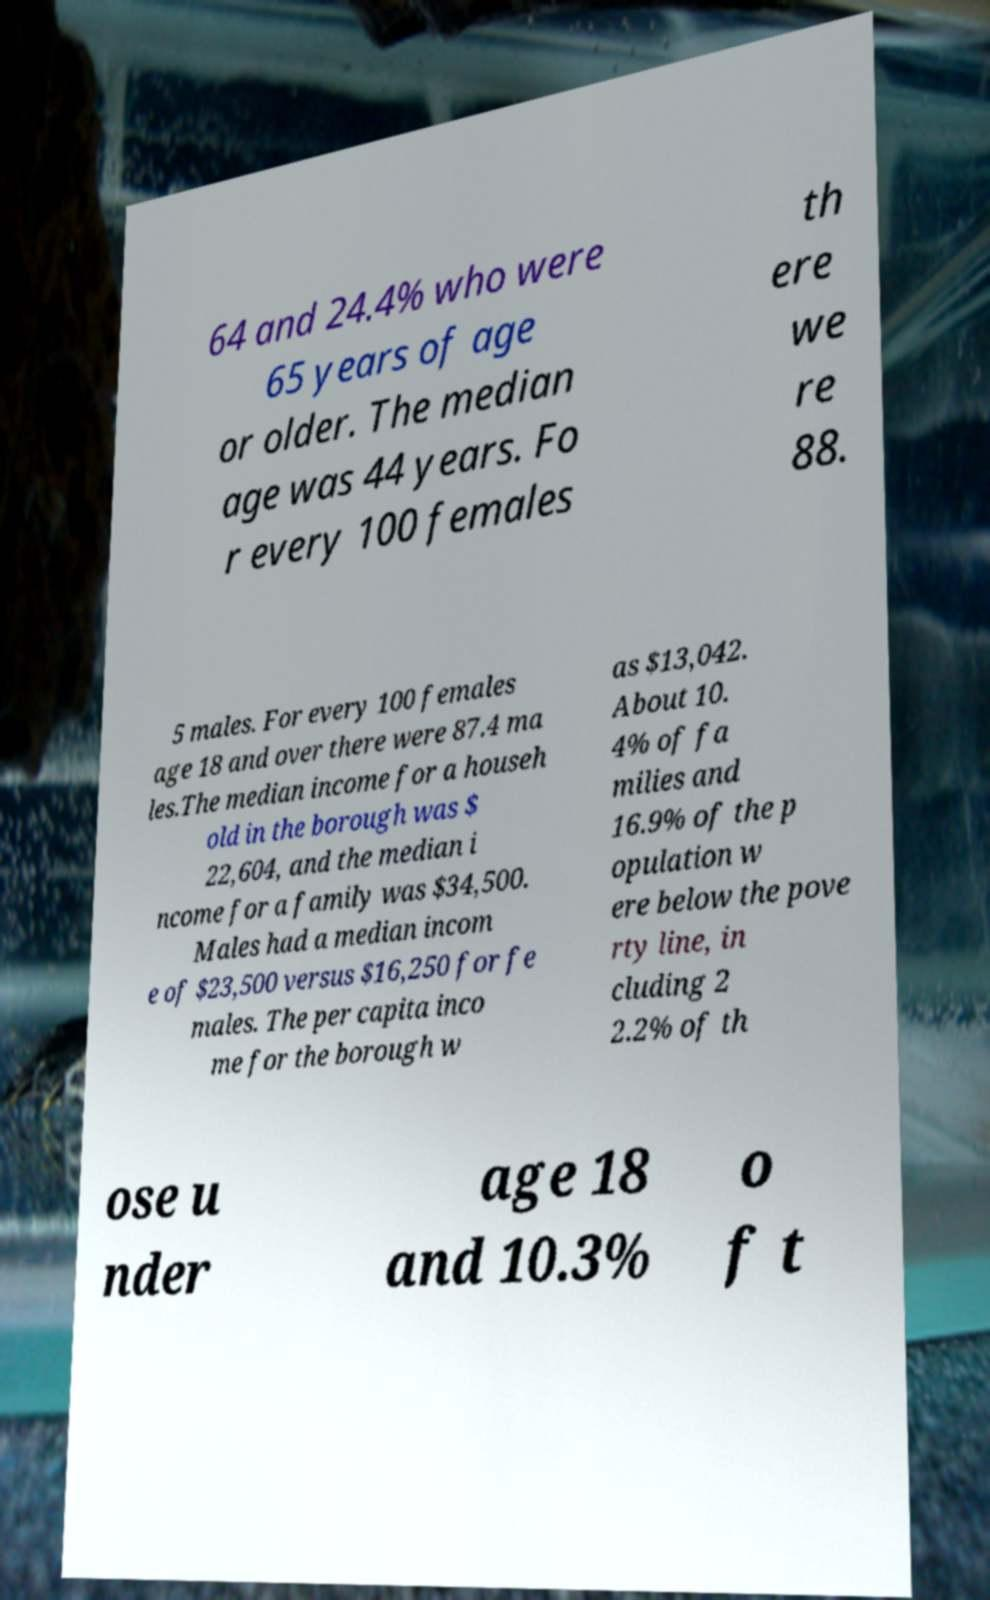Could you assist in decoding the text presented in this image and type it out clearly? 64 and 24.4% who were 65 years of age or older. The median age was 44 years. Fo r every 100 females th ere we re 88. 5 males. For every 100 females age 18 and over there were 87.4 ma les.The median income for a househ old in the borough was $ 22,604, and the median i ncome for a family was $34,500. Males had a median incom e of $23,500 versus $16,250 for fe males. The per capita inco me for the borough w as $13,042. About 10. 4% of fa milies and 16.9% of the p opulation w ere below the pove rty line, in cluding 2 2.2% of th ose u nder age 18 and 10.3% o f t 